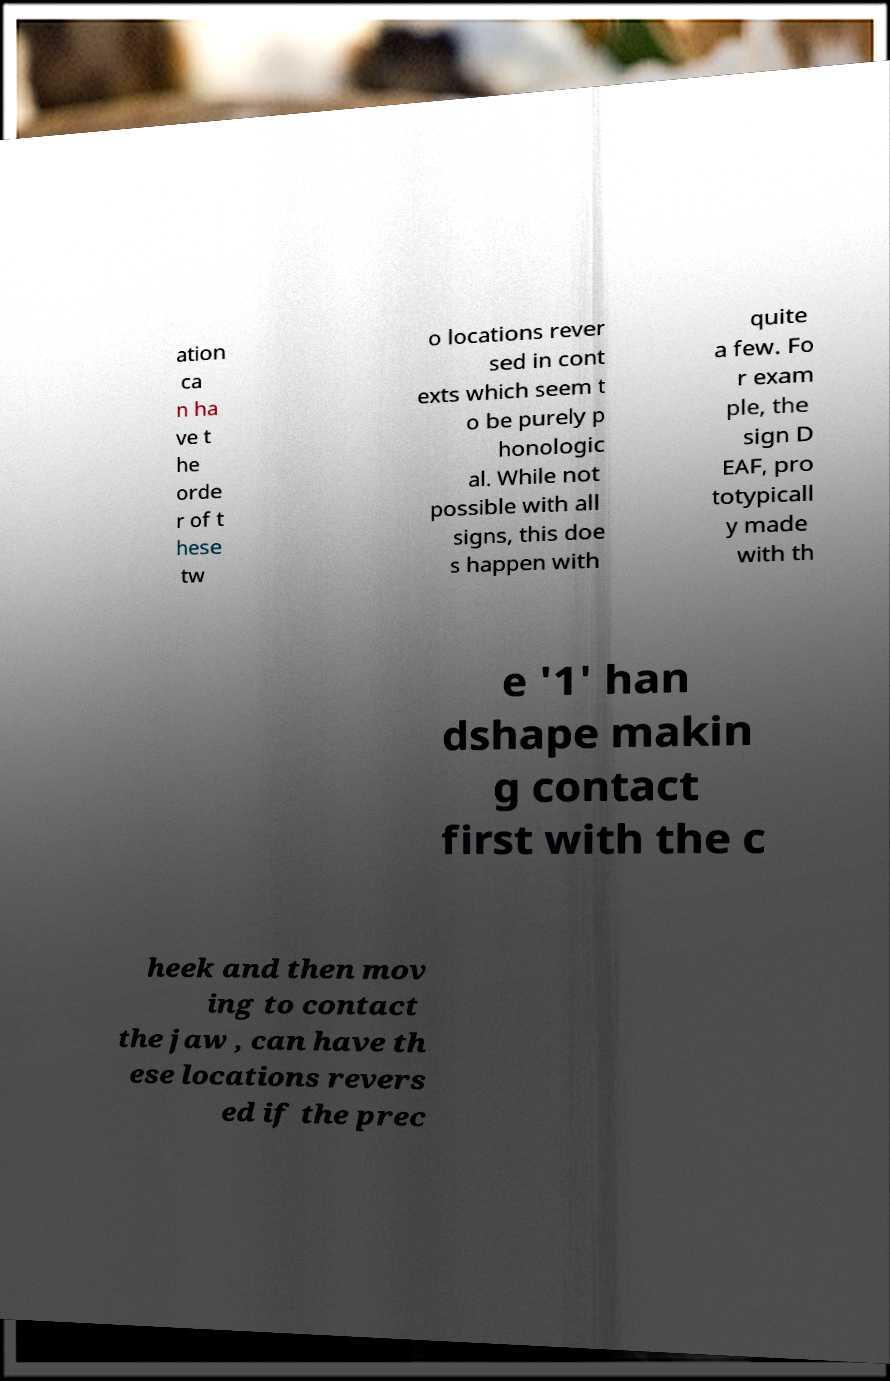Can you read and provide the text displayed in the image?This photo seems to have some interesting text. Can you extract and type it out for me? ation ca n ha ve t he orde r of t hese tw o locations rever sed in cont exts which seem t o be purely p honologic al. While not possible with all signs, this doe s happen with quite a few. Fo r exam ple, the sign D EAF, pro totypicall y made with th e '1' han dshape makin g contact first with the c heek and then mov ing to contact the jaw , can have th ese locations revers ed if the prec 